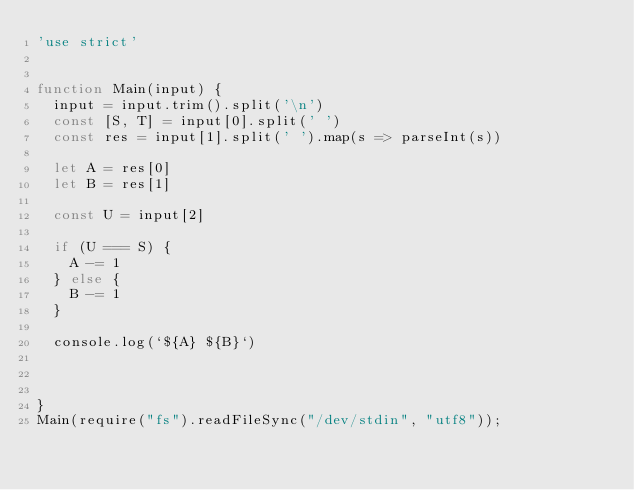Convert code to text. <code><loc_0><loc_0><loc_500><loc_500><_JavaScript_>'use strict'


function Main(input) {
  input = input.trim().split('\n')
  const [S, T] = input[0].split(' ')
  const res = input[1].split(' ').map(s => parseInt(s))

  let A = res[0]
  let B = res[1]

  const U = input[2]

  if (U === S) {
    A -= 1
  } else {
    B -= 1
  }

  console.log(`${A} ${B}`)



}
Main(require("fs").readFileSync("/dev/stdin", "utf8"));</code> 